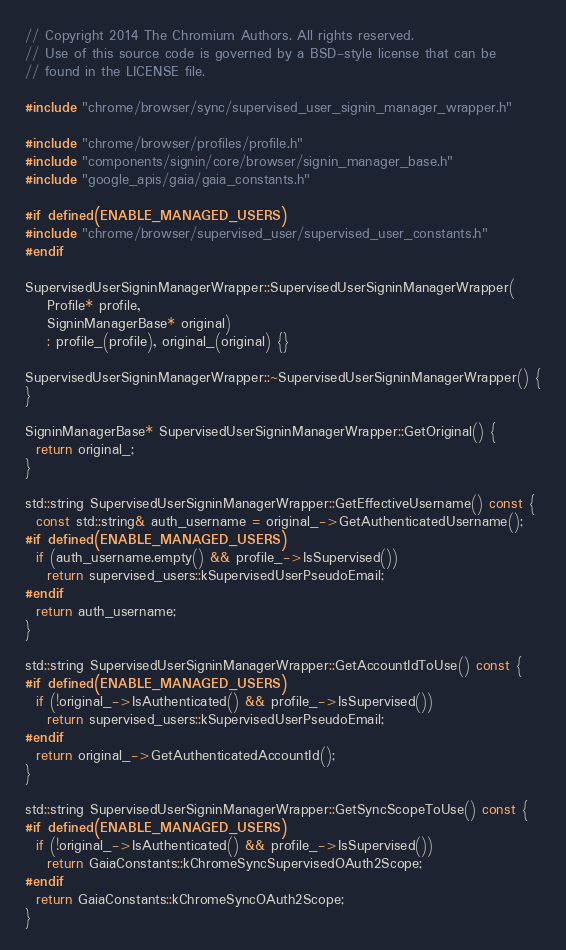Convert code to text. <code><loc_0><loc_0><loc_500><loc_500><_C++_>// Copyright 2014 The Chromium Authors. All rights reserved.
// Use of this source code is governed by a BSD-style license that can be
// found in the LICENSE file.

#include "chrome/browser/sync/supervised_user_signin_manager_wrapper.h"

#include "chrome/browser/profiles/profile.h"
#include "components/signin/core/browser/signin_manager_base.h"
#include "google_apis/gaia/gaia_constants.h"

#if defined(ENABLE_MANAGED_USERS)
#include "chrome/browser/supervised_user/supervised_user_constants.h"
#endif

SupervisedUserSigninManagerWrapper::SupervisedUserSigninManagerWrapper(
    Profile* profile,
    SigninManagerBase* original)
    : profile_(profile), original_(original) {}

SupervisedUserSigninManagerWrapper::~SupervisedUserSigninManagerWrapper() {
}

SigninManagerBase* SupervisedUserSigninManagerWrapper::GetOriginal() {
  return original_;
}

std::string SupervisedUserSigninManagerWrapper::GetEffectiveUsername() const {
  const std::string& auth_username = original_->GetAuthenticatedUsername();
#if defined(ENABLE_MANAGED_USERS)
  if (auth_username.empty() && profile_->IsSupervised())
    return supervised_users::kSupervisedUserPseudoEmail;
#endif
  return auth_username;
}

std::string SupervisedUserSigninManagerWrapper::GetAccountIdToUse() const {
#if defined(ENABLE_MANAGED_USERS)
  if (!original_->IsAuthenticated() && profile_->IsSupervised())
    return supervised_users::kSupervisedUserPseudoEmail;
#endif
  return original_->GetAuthenticatedAccountId();
}

std::string SupervisedUserSigninManagerWrapper::GetSyncScopeToUse() const {
#if defined(ENABLE_MANAGED_USERS)
  if (!original_->IsAuthenticated() && profile_->IsSupervised())
    return GaiaConstants::kChromeSyncSupervisedOAuth2Scope;
#endif
  return GaiaConstants::kChromeSyncOAuth2Scope;
}
</code> 